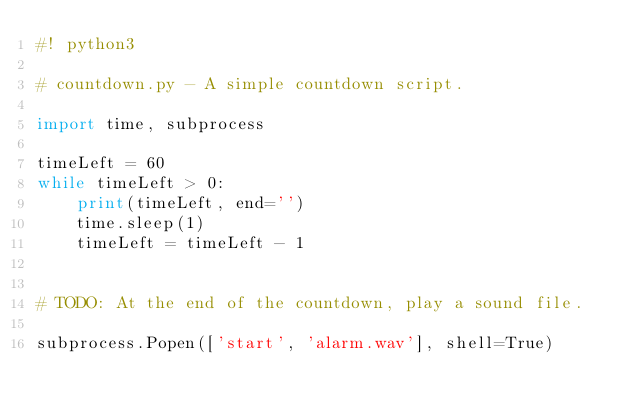<code> <loc_0><loc_0><loc_500><loc_500><_Python_>#! python3

# countdown.py - A simple countdown script.

import time, subprocess

timeLeft = 60
while timeLeft > 0:
    print(timeLeft, end='')
	time.sleep(1)
	timeLeft = timeLeft - 1
	
	
# TODO: At the end of the countdown, play a sound file. 

subprocess.Popen(['start', 'alarm.wav'], shell=True)

</code> 